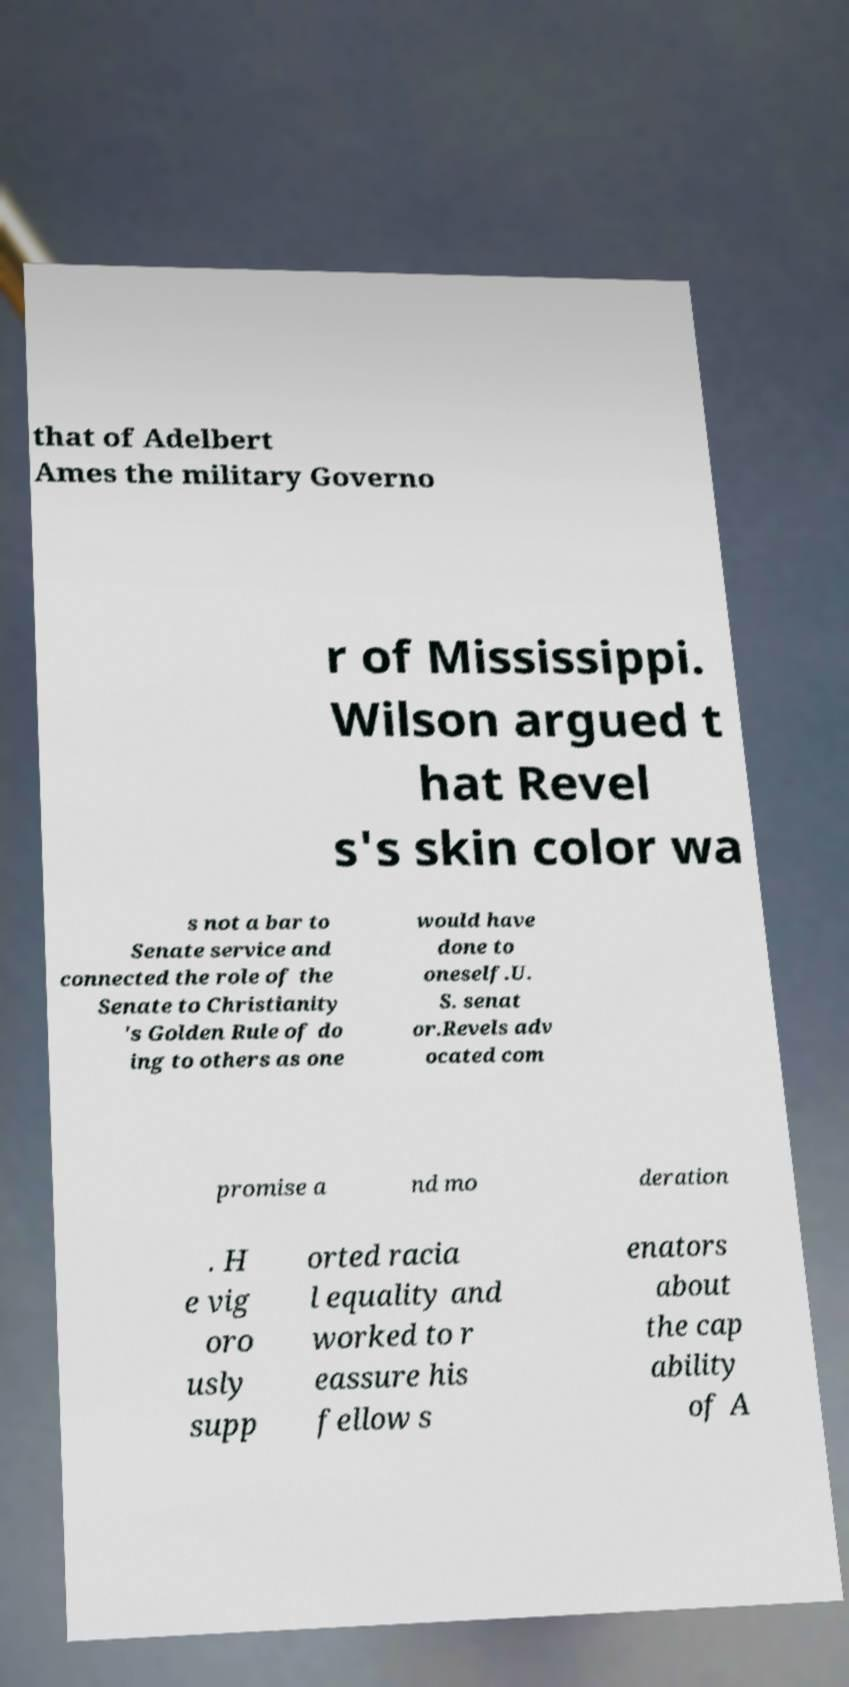Can you accurately transcribe the text from the provided image for me? that of Adelbert Ames the military Governo r of Mississippi. Wilson argued t hat Revel s's skin color wa s not a bar to Senate service and connected the role of the Senate to Christianity 's Golden Rule of do ing to others as one would have done to oneself.U. S. senat or.Revels adv ocated com promise a nd mo deration . H e vig oro usly supp orted racia l equality and worked to r eassure his fellow s enators about the cap ability of A 